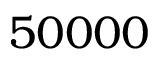Convert formula to latex. <formula><loc_0><loc_0><loc_500><loc_500>5 0 0 0 0</formula> 